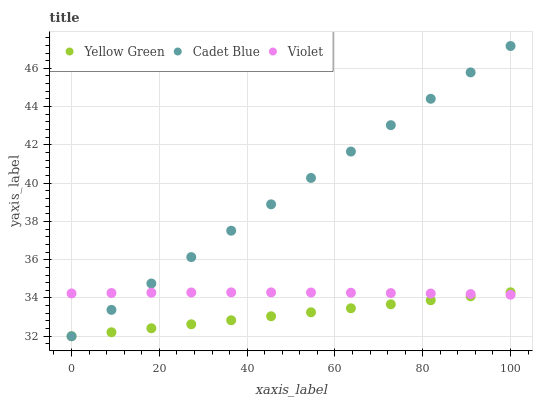Does Yellow Green have the minimum area under the curve?
Answer yes or no. Yes. Does Cadet Blue have the maximum area under the curve?
Answer yes or no. Yes. Does Violet have the minimum area under the curve?
Answer yes or no. No. Does Violet have the maximum area under the curve?
Answer yes or no. No. Is Cadet Blue the smoothest?
Answer yes or no. Yes. Is Violet the roughest?
Answer yes or no. Yes. Is Yellow Green the smoothest?
Answer yes or no. No. Is Yellow Green the roughest?
Answer yes or no. No. Does Cadet Blue have the lowest value?
Answer yes or no. Yes. Does Violet have the lowest value?
Answer yes or no. No. Does Cadet Blue have the highest value?
Answer yes or no. Yes. Does Yellow Green have the highest value?
Answer yes or no. No. Does Yellow Green intersect Violet?
Answer yes or no. Yes. Is Yellow Green less than Violet?
Answer yes or no. No. Is Yellow Green greater than Violet?
Answer yes or no. No. 